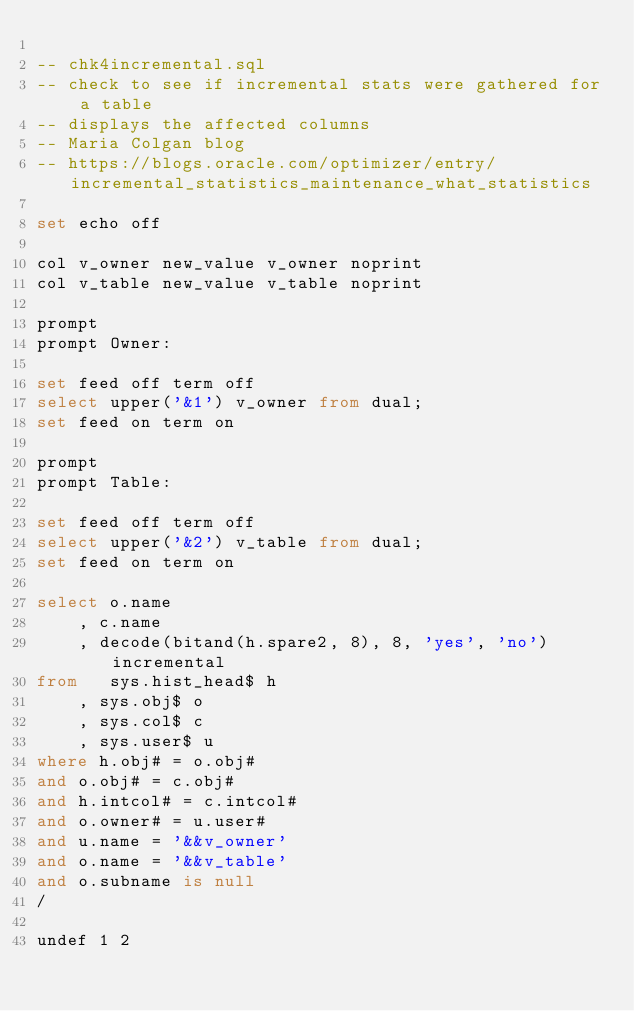Convert code to text. <code><loc_0><loc_0><loc_500><loc_500><_SQL_>
-- chk4incremental.sql
-- check to see if incremental stats were gathered for a table
-- displays the affected columns
-- Maria Colgan blog
-- https://blogs.oracle.com/optimizer/entry/incremental_statistics_maintenance_what_statistics

set echo off

col v_owner new_value v_owner noprint
col v_table new_value v_table noprint

prompt
prompt Owner:

set feed off term off
select upper('&1') v_owner from dual;
set feed on term on

prompt
prompt Table: 

set feed off term off
select upper('&2') v_table from dual;
set feed on term on

select o.name
	, c.name
	, decode(bitand(h.spare2, 8), 8, 'yes', 'no') incremental
from   sys.hist_head$ h
	, sys.obj$ o
	, sys.col$ c
	, sys.user$ u
where h.obj# = o.obj#
and o.obj# = c.obj#
and h.intcol# = c.intcol#
and o.owner# = u.user#
and u.name = '&&v_owner'
and o.name = '&&v_table'
and o.subname is null
/

undef 1 2


</code> 